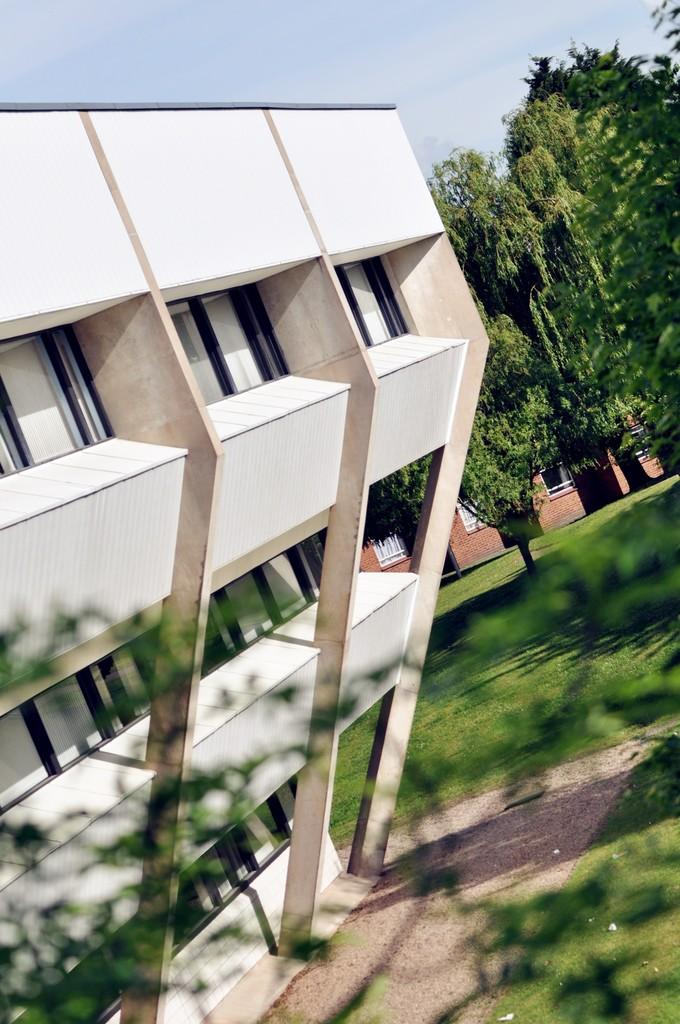What type of outdoor space is visible in the image? There is a yard in the image. What can be found in the yard? The yard contains trees. What structures are present in the image? There are buildings in the image. What is visible in the background of the image? The sky is visible behind the buildings in the image. What type of rod is being used to cook breakfast in the image? There is no rod or breakfast present in the image. What is the yard being used for in the image? The image does not provide information about the purpose of the yard. 